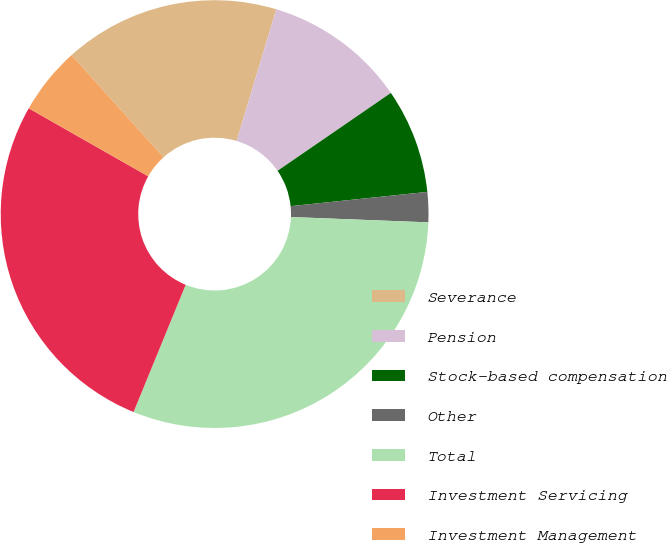<chart> <loc_0><loc_0><loc_500><loc_500><pie_chart><fcel>Severance<fcel>Pension<fcel>Stock-based compensation<fcel>Other<fcel>Total<fcel>Investment Servicing<fcel>Investment Management<nl><fcel>16.32%<fcel>10.76%<fcel>7.93%<fcel>2.27%<fcel>30.57%<fcel>27.05%<fcel>5.1%<nl></chart> 